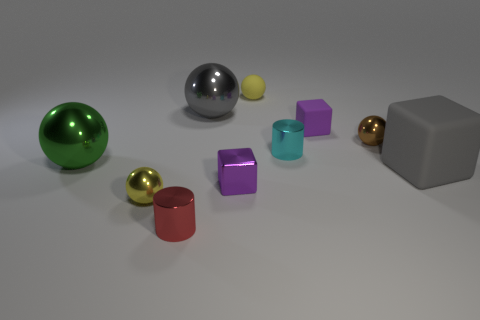What number of tiny spheres are in front of the large rubber cube and behind the gray ball?
Provide a short and direct response. 0. What number of other objects are there of the same size as the matte sphere?
Your answer should be compact. 6. Is the shape of the yellow object that is in front of the small brown thing the same as the small brown object behind the gray rubber block?
Your response must be concise. Yes. There is a small cyan thing; are there any tiny yellow things behind it?
Offer a terse response. Yes. There is a tiny rubber object that is the same shape as the green metal thing; what is its color?
Provide a short and direct response. Yellow. Is there anything else that is the same shape as the big rubber thing?
Provide a short and direct response. Yes. What material is the large ball that is in front of the brown metal object?
Your answer should be very brief. Metal. What is the size of the cyan thing that is the same shape as the tiny red object?
Offer a very short reply. Small. How many tiny cyan objects are the same material as the brown ball?
Your response must be concise. 1. What number of metal balls have the same color as the matte ball?
Make the answer very short. 1. 